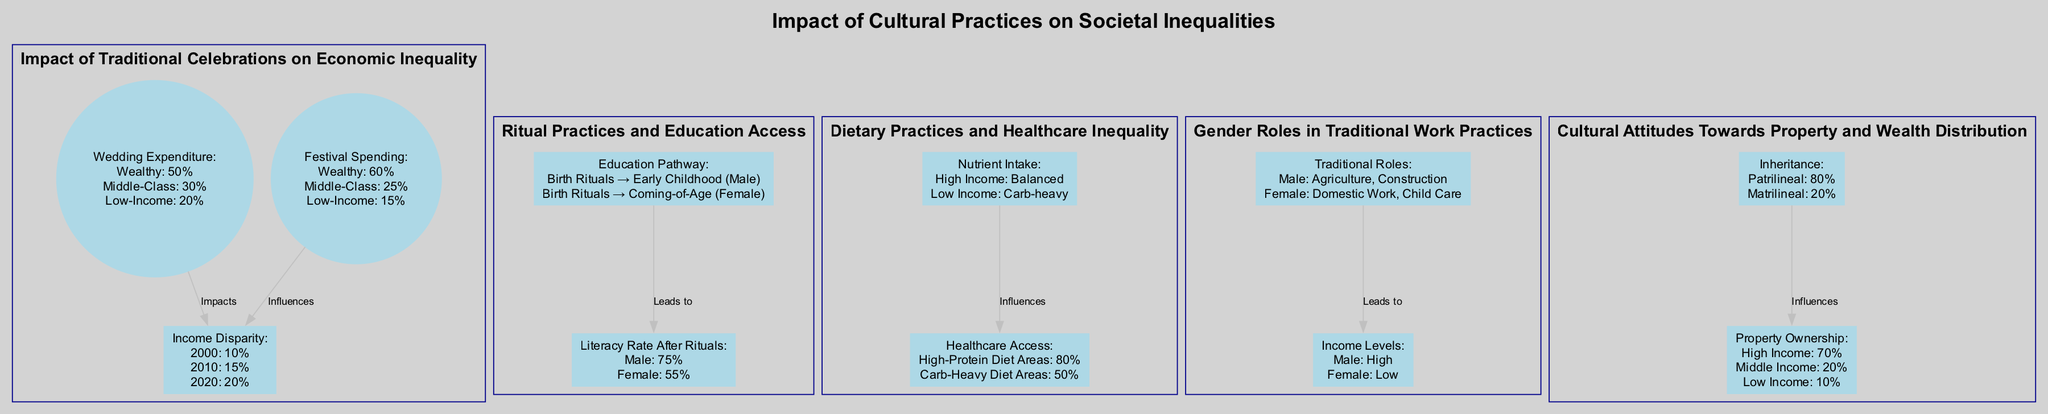What is the percentage of wedding expenditure for wealthy families? The diagram indicates that wealthy families account for 50% of the wedding expenditure. This is found in the pie chart labeled 'Wedding Expenditure Breakdown'.
Answer: 50% What are the key events listed on the income disparity timeline? The timeline outlines three key events: 'Introduction of New Tax Policy' in 2000, 'National Economic Crisis' in 2010, and 'Pandemic Impact' in 2020. These events show triggers for income disparity changes.
Answer: Introduction of New Tax Policy, National Economic Crisis, Pandemic Impact What is the average funeral spending in rural areas? The map shows that the average spending on funerals in rural areas is 1000. This information is directly taken from the 'Regional Variations in Spending on Funerals' map.
Answer: 1000 Which gender has a higher literacy rate after initiation rituals? The bar graph indicates that the male literacy rate after initiation rituals is 75%, while for females it is 55%. Thus, males have a higher literacy rate.
Answer: Male How does access to healthcare facilities compare between high-protein and carb-heavy diet areas? According to the heat map, high-protein diet areas have an access rate of 80% to healthcare facilities, while carb-heavy diet areas have 50% access. This shows a disparity in healthcare access based on dietary practices.
Answer: 80% and 50% What are the responsibilities listed for males in the gender roles diagram? The Venn diagram specifies that males have responsibilities in agriculture and construction. These roles are depicted as high-income activities, contrasting with female responsibilities outlined in the same diagram.
Answer: Agriculture, Construction How do inheritance practices in patrilineal communities compare to matrilineal communities? The infographic indicates that patrilineal communities represent 80% of inheritance practices, while matrilineal communities make up 20%. This shows a significant preference for patrilineal inheritance patterns.
Answer: 80% and 20% What is the income level associated with traditional female roles in labor? The diagram notes that traditional female roles, including domestic work and child care, are associated with a low-income level, as per the Venn diagram detailing responsibilities and incomes.
Answer: Low What was the income gap in 2020? The timeline states that the income gap in 2020 was 20%. This figure represents the most recent data point on income disparity in the diagram.
Answer: 20% 